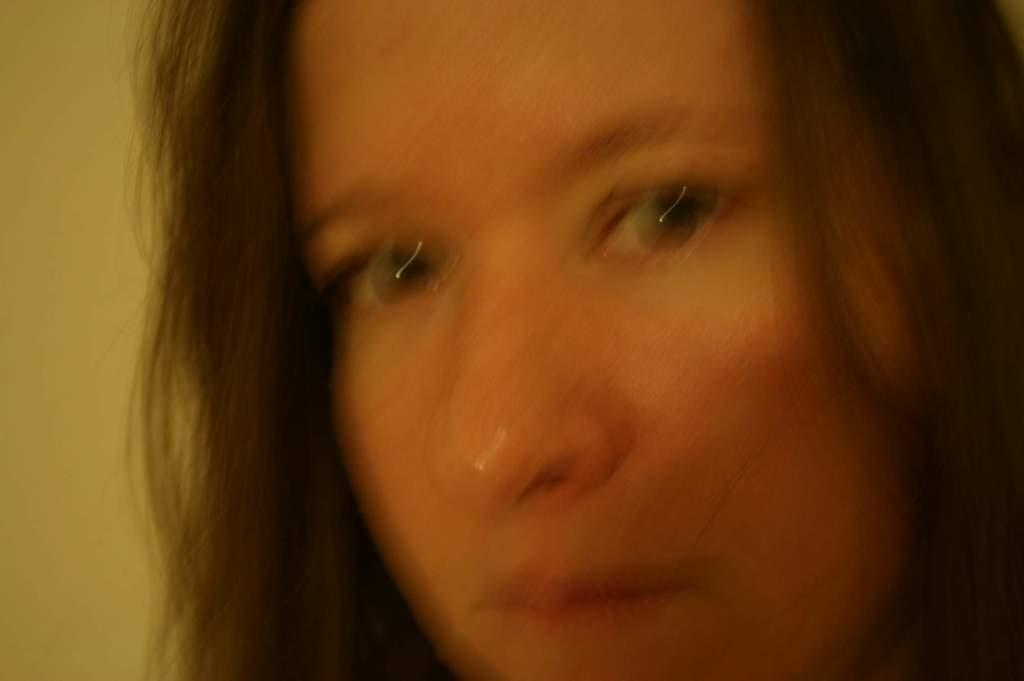What is the main subject of the picture? The main subject of the picture is a blurred image of a woman's face. What type of receipt can be seen in the woman's hand in the image? There is no receipt visible in the image, as it only features a blurred image of a woman's face. 